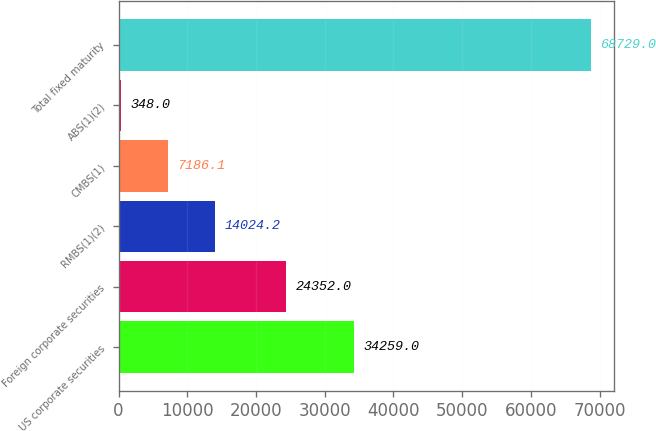Convert chart. <chart><loc_0><loc_0><loc_500><loc_500><bar_chart><fcel>US corporate securities<fcel>Foreign corporate securities<fcel>RMBS(1)(2)<fcel>CMBS(1)<fcel>ABS(1)(2)<fcel>Total fixed maturity<nl><fcel>34259<fcel>24352<fcel>14024.2<fcel>7186.1<fcel>348<fcel>68729<nl></chart> 